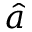<formula> <loc_0><loc_0><loc_500><loc_500>\hat { a }</formula> 